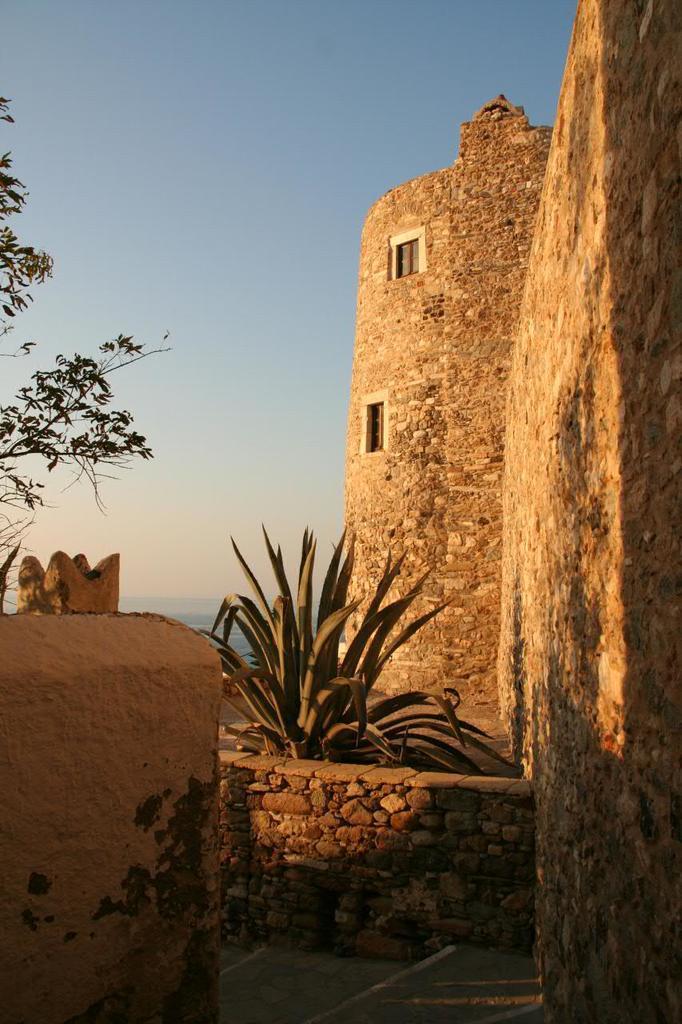Can you describe this image briefly? In this image we can see a stone structure. There are windows. There are plants. In the background of the image there is sky. To the left side of the image there is tree. 